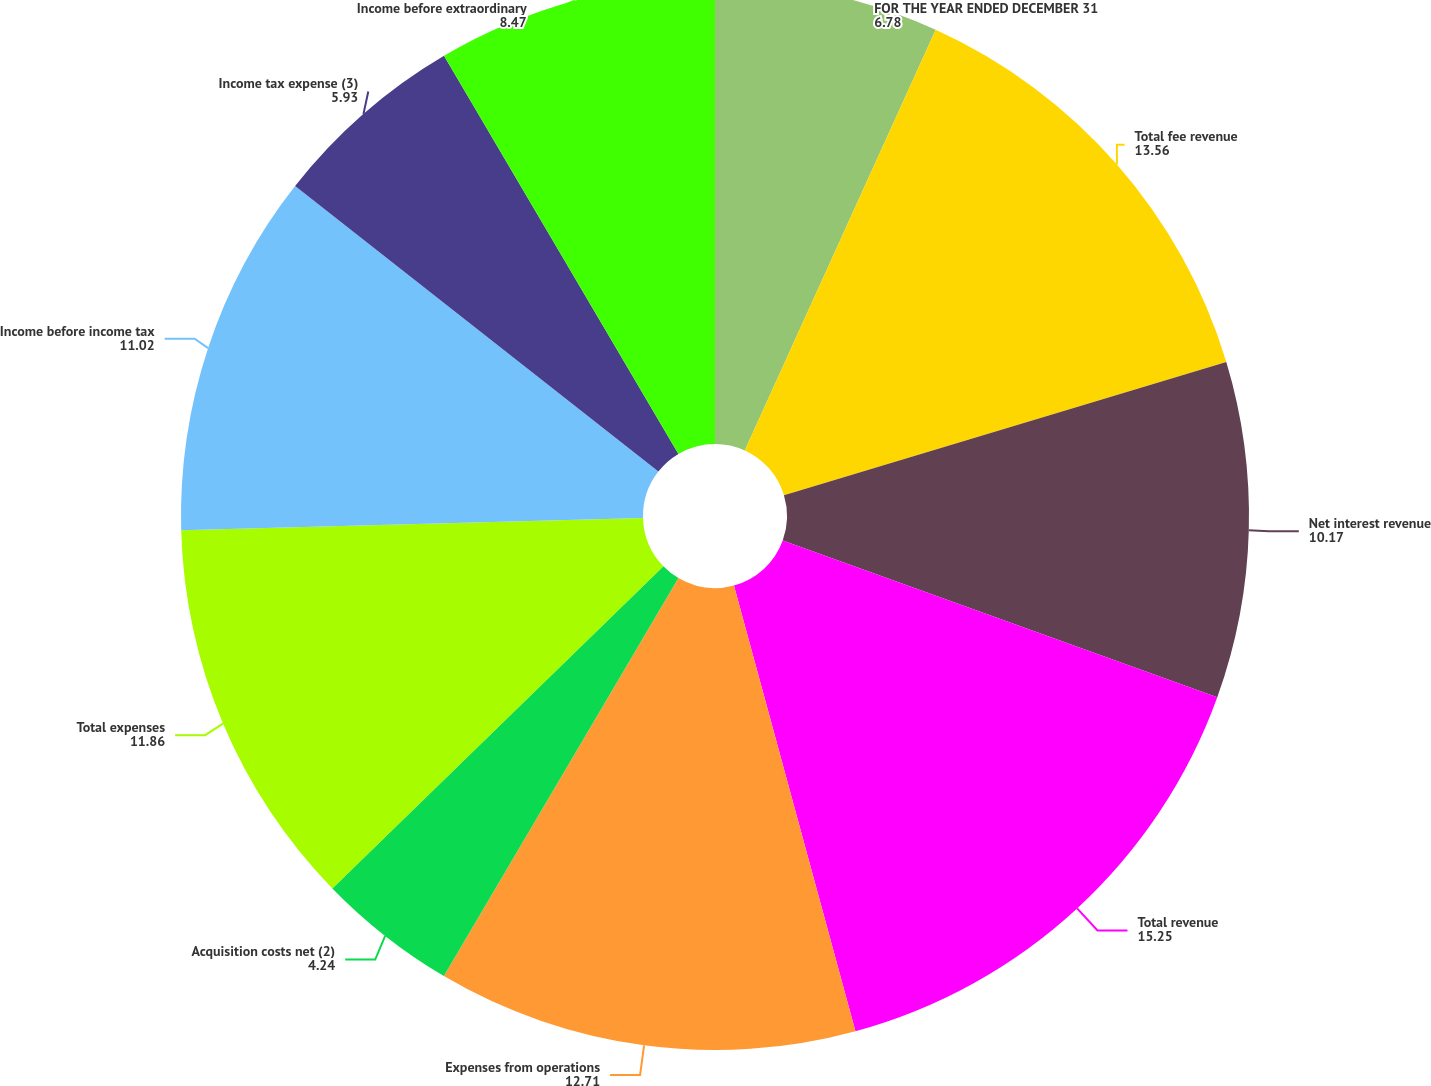Convert chart to OTSL. <chart><loc_0><loc_0><loc_500><loc_500><pie_chart><fcel>FOR THE YEAR ENDED DECEMBER 31<fcel>Total fee revenue<fcel>Net interest revenue<fcel>Total revenue<fcel>Expenses from operations<fcel>Acquisition costs net (2)<fcel>Total expenses<fcel>Income before income tax<fcel>Income tax expense (3)<fcel>Income before extraordinary<nl><fcel>6.78%<fcel>13.56%<fcel>10.17%<fcel>15.25%<fcel>12.71%<fcel>4.24%<fcel>11.86%<fcel>11.02%<fcel>5.93%<fcel>8.47%<nl></chart> 